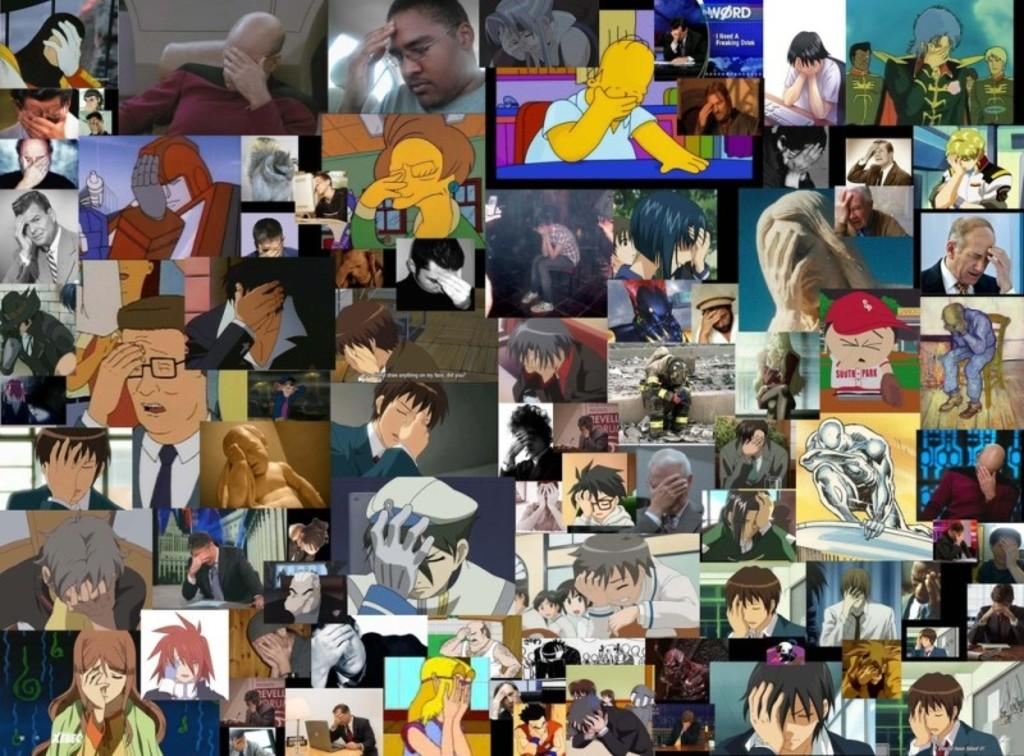What type of image is shown in the picture? The image is an edited collage of images. Can you describe the people in the image? There is a group of persons in the image. What else can be seen in the image besides the people? There is text visible in the image, as well as sky and other objects. How many cacti are present in the image? There are no cacti visible in the image; it is a collage of images that does not include any cacti. 